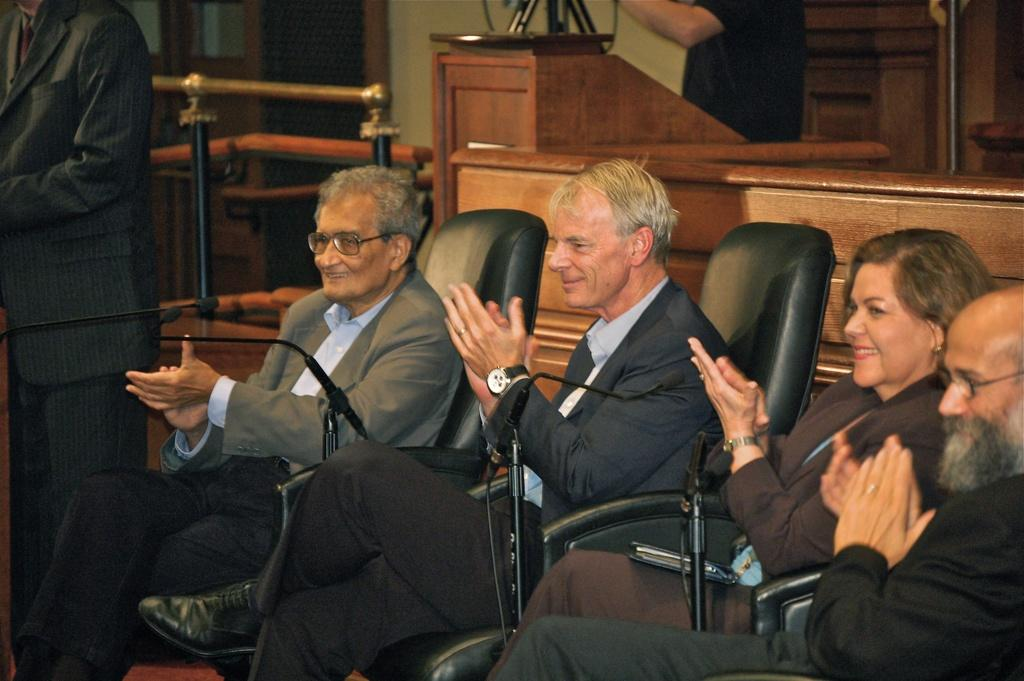What are the people in the image doing? The people in the image are sitting on chairs in the center of the image. What is the position of the man in the image? There is a man standing on the left side of the image. What can be seen in the background of the image? There is a table and a wall in the background of the image. What type of ear is visible on the table in the image? There is no ear present on the table in the image. 